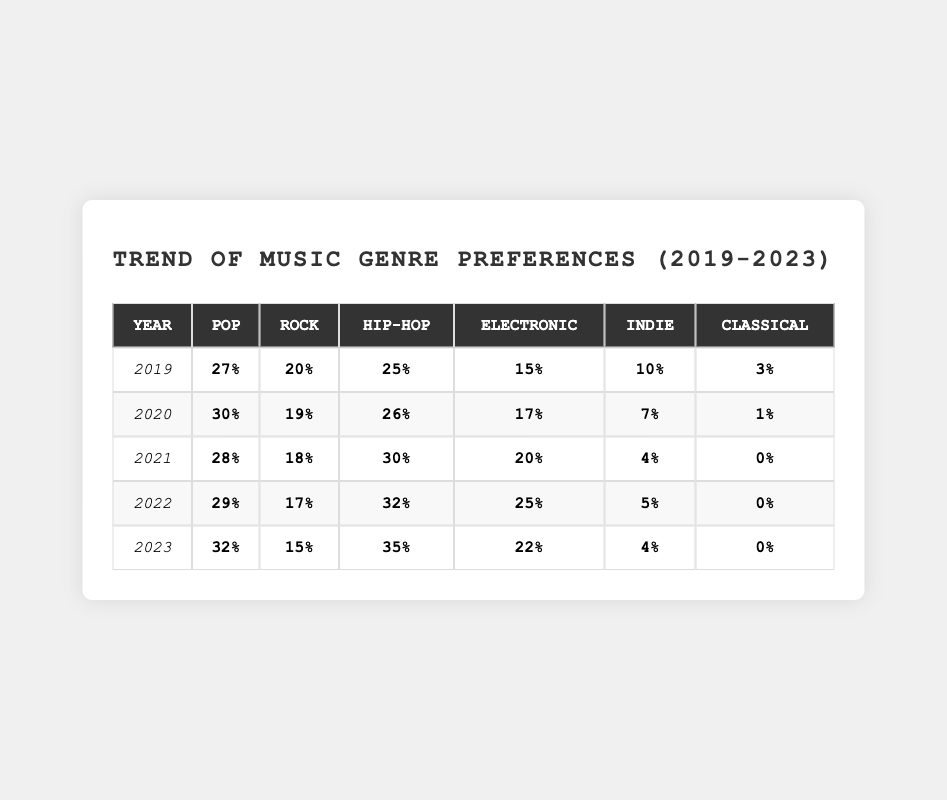What was the percentage of Hip-Hop preference in 2021? In the row for the year 2021, the Hip-Hop percentage is directly listed as 30%.
Answer: 30% Which year had the highest percentage of Pop preference? By examining each year's Pop percentages, 2023 has the highest value at 32%, compared to 30% in 2020, 29% in 2022, 28% in 2021, and 27% in 2019.
Answer: 2023 What is the difference in percentage preference for Rock between 2019 and 2023? The Rock percentage for 2019 is 20% and for 2023 is 15%. The difference is 20% - 15% = 5%.
Answer: 5% Is the preference for Electronic music increasing from 2019 to 2023? The Electronic percentages from 2019 to 2023 are 15%, 17%, 20%, 25%, and 22%, showing that it peaked in 2022 and then decreased in 2023. Therefore, it is not consistently increasing.
Answer: No What was the average preference percentage for Indie music over the five years? The Indie percentages are 10%, 7%, 4%, 5%, and 4%. Summing these gives 10 + 7 + 4 + 5 + 4 = 30%. There are 5 years, so the average is 30% / 5 = 6%.
Answer: 6% Which genre saw the largest increase in preference from 2019 to 2023? For each genre, we can calculate the change: Pop increased from 27% to 32% (5%), Rock decreased from 20% to 15% (5%), Hip-Hop increased from 25% to 35% (10%), Electronic increased from 15% to 22% (7%), Indie decreased from 10% to 4% (6%), Classical decreased from 3% to 0% (3%). The largest increase is for Hip-Hop at 10%.
Answer: Hip-Hop In which year was there no preference for Classical music? By reviewing the percentages for Classical music, there is a 0% preference in the years 2021, 2022, and 2023.
Answer: 2021, 2022, and 2023 What percentage of overall preferences does Rock represent in 2022? The percentage for Rock in 2022 is given as 17%. This is a direct retrieval from the table.
Answer: 17% If we sum up all the genre preferences in 2023, what is the total? The percentages for 2023 are: Pop 32%, Rock 15%, Hip-Hop 35%, Electronic 22%, Indie 4%, and Classical 0%. Adding these gives 32 + 15 + 35 + 22 + 4 + 0 = 108%.
Answer: 108% Which genre had the lowest preference in 2020? Reviewing the percentages for all genres in 2020, Classical had the lowest at 1% compared to all other genres.
Answer: Classical 